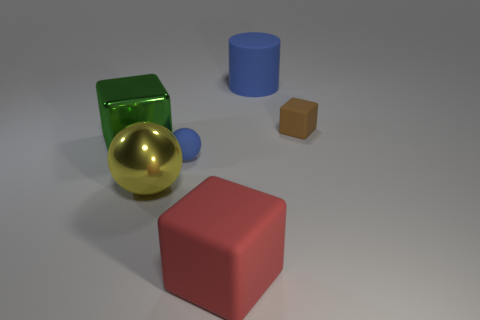Add 3 green metal cubes. How many objects exist? 9 Subtract all big cubes. How many cubes are left? 1 Add 6 green metal blocks. How many green metal blocks are left? 7 Add 6 purple metallic objects. How many purple metallic objects exist? 6 Subtract 0 red cylinders. How many objects are left? 6 Subtract all balls. How many objects are left? 4 Subtract all purple cubes. Subtract all yellow spheres. How many cubes are left? 3 Subtract all tiny gray cylinders. Subtract all green objects. How many objects are left? 5 